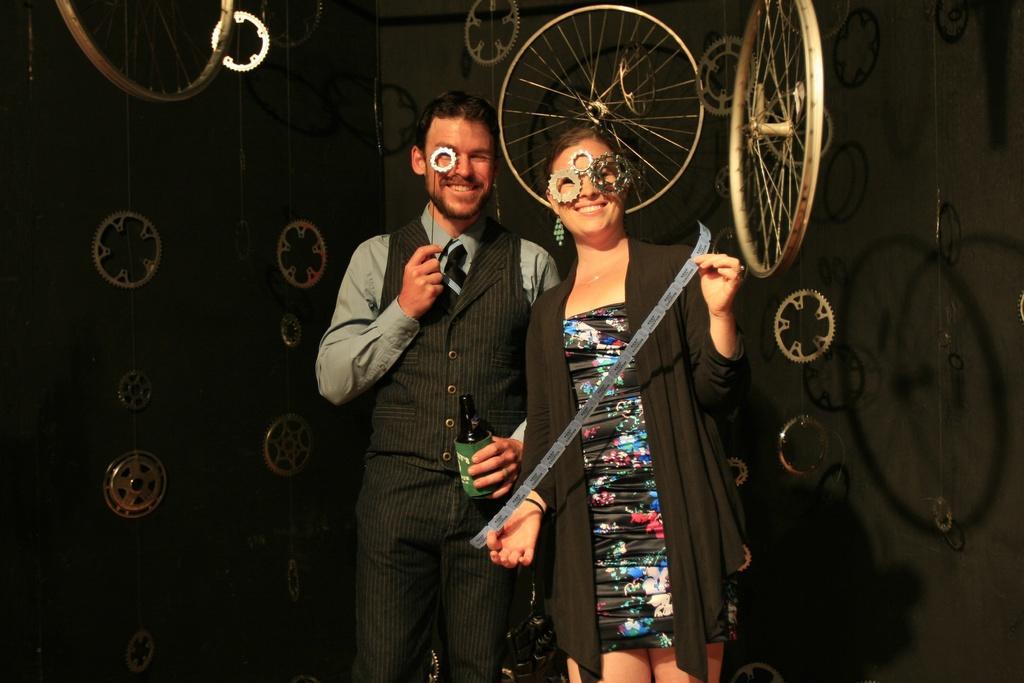Please provide a concise description of this image. In the center of the image we can see two people are standing and smiling and wearing the black dresses and a lady is holding an object and a man is holding a bottle, object. In the background of the image we can see the wheels and the wall. 